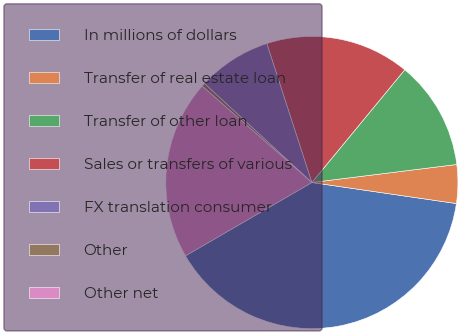<chart> <loc_0><loc_0><loc_500><loc_500><pie_chart><fcel>In millions of dollars<fcel>Transfer of real estate loan<fcel>Transfer of other loan<fcel>Sales or transfers of various<fcel>FX translation consumer<fcel>Other<fcel>Other net<nl><fcel>39.33%<fcel>4.27%<fcel>12.06%<fcel>15.96%<fcel>8.16%<fcel>0.37%<fcel>19.85%<nl></chart> 